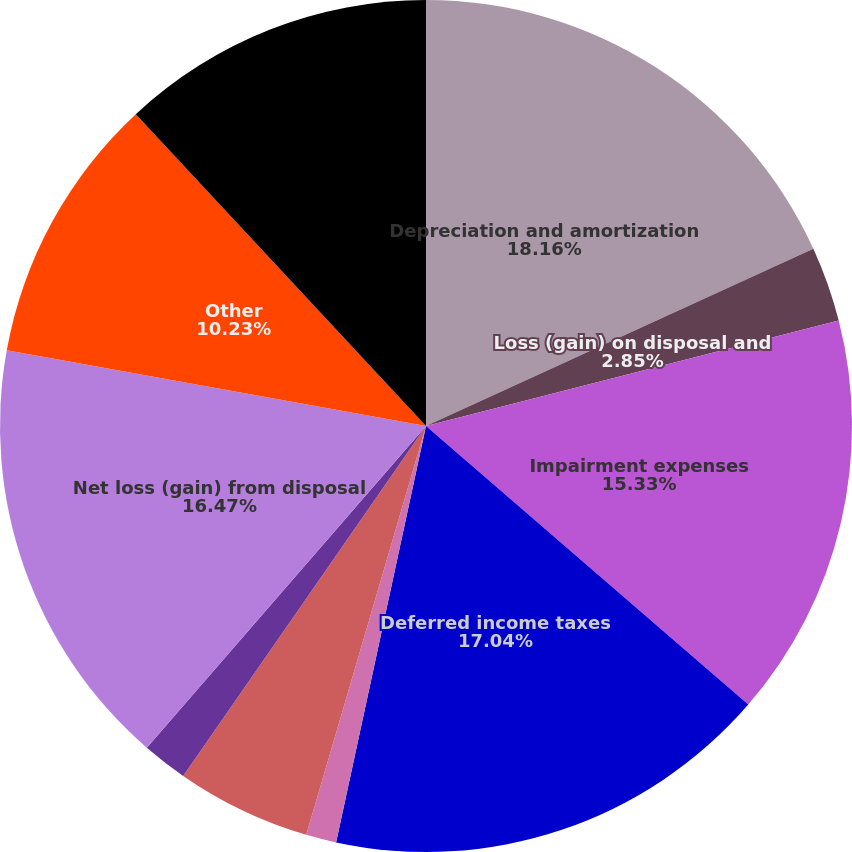Convert chart to OTSL. <chart><loc_0><loc_0><loc_500><loc_500><pie_chart><fcel>Depreciation and amortization<fcel>Loss (gain) on disposal and<fcel>Impairment expenses<fcel>Deferred income taxes<fcel>Provisions for contingencies<fcel>Loss on extinguishment of debt<fcel>Loss on sale and disposal of<fcel>Net loss (gain) from disposal<fcel>Other<fcel>(Increase) decrease in<nl><fcel>18.17%<fcel>2.85%<fcel>15.33%<fcel>17.04%<fcel>1.15%<fcel>5.12%<fcel>1.72%<fcel>16.47%<fcel>10.23%<fcel>11.93%<nl></chart> 